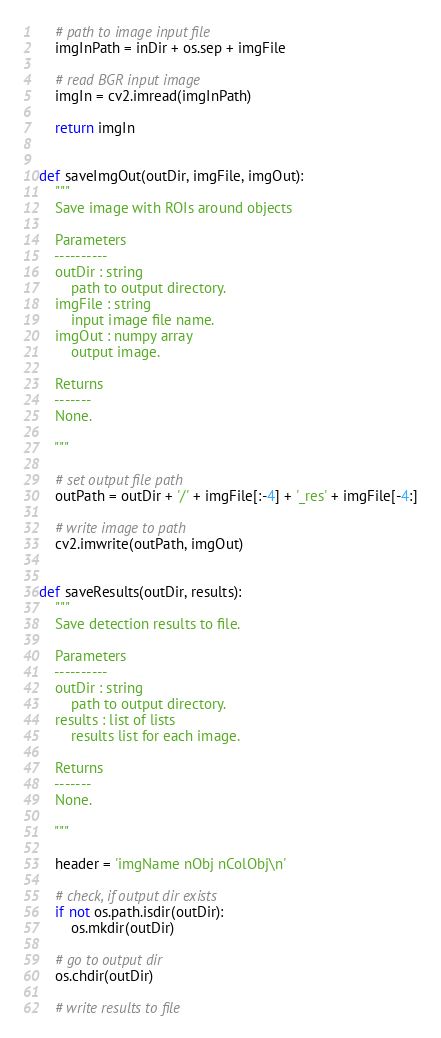Convert code to text. <code><loc_0><loc_0><loc_500><loc_500><_Python_>    # path to image input file
    imgInPath = inDir + os.sep + imgFile
            
    # read BGR input image                
    imgIn = cv2.imread(imgInPath)
    
    return imgIn


def saveImgOut(outDir, imgFile, imgOut):
    """
    Save image with ROIs around objects 

    Parameters
    ----------
    outDir : string
        path to output directory.
    imgFile : string
        input image file name.
    imgOut : numpy array
        output image.
        
    Returns
    -------
    None.

    """
    
    # set output file path
    outPath = outDir + '/' + imgFile[:-4] + '_res' + imgFile[-4:]
    
    # write image to path
    cv2.imwrite(outPath, imgOut)

    
def saveResults(outDir, results):
    """
    Save detection results to file.
    
    Parameters
    ----------
    outDir : string
        path to output directory.
    results : list of lists
        results list for each image.

    Returns
    -------
    None.

    """
    
    header = 'imgName nObj nColObj\n'
    
    # check, if output dir exists
    if not os.path.isdir(outDir):
        os.mkdir(outDir)
    
    # go to output dir
    os.chdir(outDir)

    # write results to file</code> 